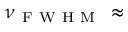<formula> <loc_0><loc_0><loc_500><loc_500>\nu _ { F W H M } \, \approx</formula> 